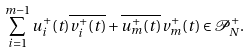<formula> <loc_0><loc_0><loc_500><loc_500>\sum _ { i = 1 } ^ { m - 1 } u ^ { + } _ { i } ( t ) \overline { v _ { i } ^ { + } ( t ) } + \overline { u _ { m } ^ { + } ( t ) } v _ { m } ^ { + } ( t ) \in \mathcal { P } _ { N } ^ { + } .</formula> 